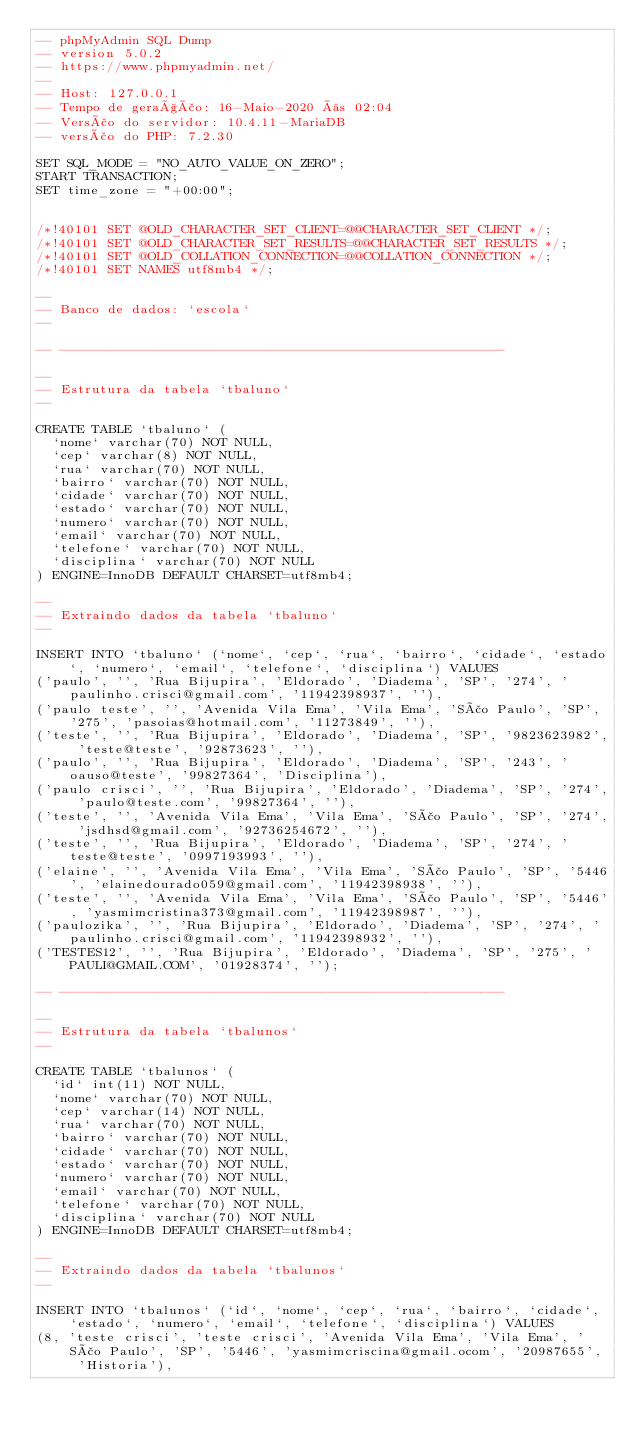<code> <loc_0><loc_0><loc_500><loc_500><_SQL_>-- phpMyAdmin SQL Dump
-- version 5.0.2
-- https://www.phpmyadmin.net/
--
-- Host: 127.0.0.1
-- Tempo de geração: 16-Maio-2020 às 02:04
-- Versão do servidor: 10.4.11-MariaDB
-- versão do PHP: 7.2.30

SET SQL_MODE = "NO_AUTO_VALUE_ON_ZERO";
START TRANSACTION;
SET time_zone = "+00:00";


/*!40101 SET @OLD_CHARACTER_SET_CLIENT=@@CHARACTER_SET_CLIENT */;
/*!40101 SET @OLD_CHARACTER_SET_RESULTS=@@CHARACTER_SET_RESULTS */;
/*!40101 SET @OLD_COLLATION_CONNECTION=@@COLLATION_CONNECTION */;
/*!40101 SET NAMES utf8mb4 */;

--
-- Banco de dados: `escola`
--

-- --------------------------------------------------------

--
-- Estrutura da tabela `tbaluno`
--

CREATE TABLE `tbaluno` (
  `nome` varchar(70) NOT NULL,
  `cep` varchar(8) NOT NULL,
  `rua` varchar(70) NOT NULL,
  `bairro` varchar(70) NOT NULL,
  `cidade` varchar(70) NOT NULL,
  `estado` varchar(70) NOT NULL,
  `numero` varchar(70) NOT NULL,
  `email` varchar(70) NOT NULL,
  `telefone` varchar(70) NOT NULL,
  `disciplina` varchar(70) NOT NULL
) ENGINE=InnoDB DEFAULT CHARSET=utf8mb4;

--
-- Extraindo dados da tabela `tbaluno`
--

INSERT INTO `tbaluno` (`nome`, `cep`, `rua`, `bairro`, `cidade`, `estado`, `numero`, `email`, `telefone`, `disciplina`) VALUES
('paulo', '', 'Rua Bijupira', 'Eldorado', 'Diadema', 'SP', '274', 'paulinho.crisci@gmail.com', '11942398937', ''),
('paulo teste', '', 'Avenida Vila Ema', 'Vila Ema', 'São Paulo', 'SP', '275', 'pasoias@hotmail.com', '11273849', ''),
('teste', '', 'Rua Bijupira', 'Eldorado', 'Diadema', 'SP', '9823623982', 'teste@teste', '92873623', ''),
('paulo', '', 'Rua Bijupira', 'Eldorado', 'Diadema', 'SP', '243', 'oauso@teste', '99827364', 'Disciplina'),
('paulo crisci', '', 'Rua Bijupira', 'Eldorado', 'Diadema', 'SP', '274', 'paulo@teste.com', '99827364', ''),
('teste', '', 'Avenida Vila Ema', 'Vila Ema', 'São Paulo', 'SP', '274', 'jsdhsd@gmail.com', '92736254672', ''),
('teste', '', 'Rua Bijupira', 'Eldorado', 'Diadema', 'SP', '274', 'teste@teste', '0997193993', ''),
('elaine', '', 'Avenida Vila Ema', 'Vila Ema', 'São Paulo', 'SP', '5446', 'elainedourado059@gmail.com', '11942398938', ''),
('teste', '', 'Avenida Vila Ema', 'Vila Ema', 'São Paulo', 'SP', '5446', 'yasmimcristina373@gmail.com', '11942398987', ''),
('paulozika', '', 'Rua Bijupira', 'Eldorado', 'Diadema', 'SP', '274', 'paulinho.crisci@gmail.com', '11942398932', ''),
('TESTES12', '', 'Rua Bijupira', 'Eldorado', 'Diadema', 'SP', '275', 'PAULI@GMAIL.COM', '01928374', '');

-- --------------------------------------------------------

--
-- Estrutura da tabela `tbalunos`
--

CREATE TABLE `tbalunos` (
  `id` int(11) NOT NULL,
  `nome` varchar(70) NOT NULL,
  `cep` varchar(14) NOT NULL,
  `rua` varchar(70) NOT NULL,
  `bairro` varchar(70) NOT NULL,
  `cidade` varchar(70) NOT NULL,
  `estado` varchar(70) NOT NULL,
  `numero` varchar(70) NOT NULL,
  `email` varchar(70) NOT NULL,
  `telefone` varchar(70) NOT NULL,
  `disciplina` varchar(70) NOT NULL
) ENGINE=InnoDB DEFAULT CHARSET=utf8mb4;

--
-- Extraindo dados da tabela `tbalunos`
--

INSERT INTO `tbalunos` (`id`, `nome`, `cep`, `rua`, `bairro`, `cidade`, `estado`, `numero`, `email`, `telefone`, `disciplina`) VALUES
(8, 'teste crisci', 'teste crisci', 'Avenida Vila Ema', 'Vila Ema', 'São Paulo', 'SP', '5446', 'yasmimcriscina@gmail.ocom', '20987655', 'Historia'),</code> 